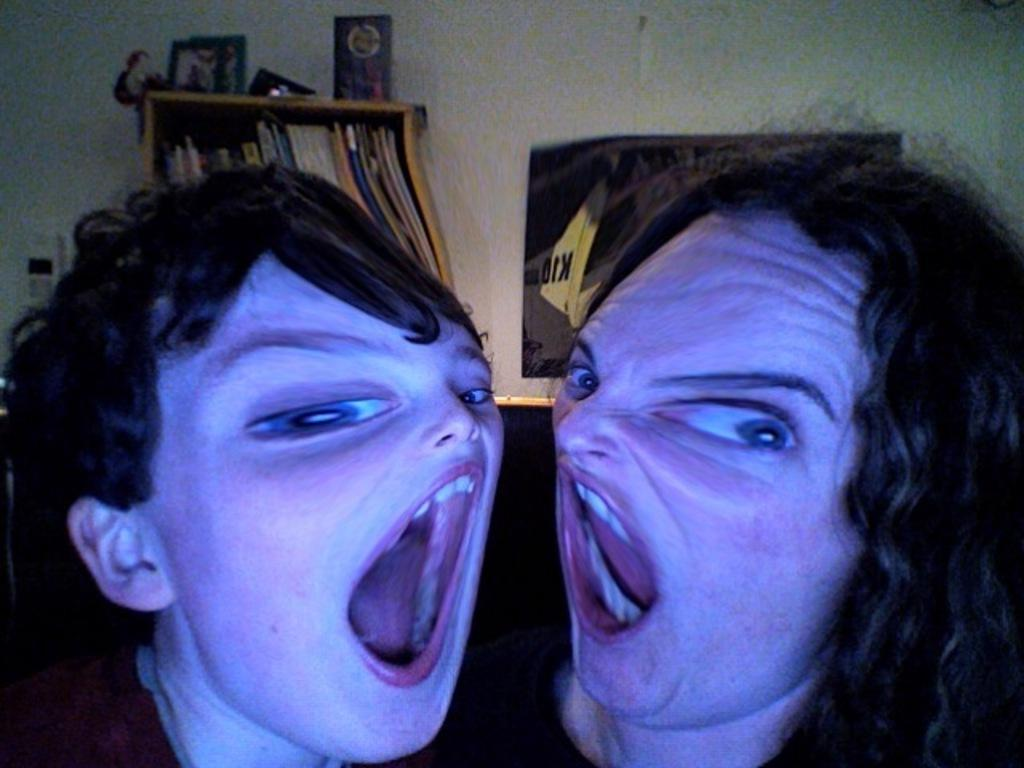What can be seen on the wall in the image? There are objects on the wall in the image. Who or what is present in the image besides the wall? There are people in the image. What is located below the wall in the image? There is a shelf with objects in the image. What type of decoration is present on the wall in the image? There is a poster in the image. Can you see a rabbit holding a pen in the image? There is no rabbit or pen present in the image. How many arms does the person in the image have? The provided facts do not mention the number of arms for the person in the image, so we cannot definitively answer this question. 